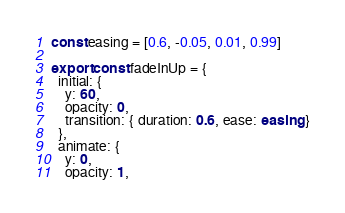Convert code to text. <code><loc_0><loc_0><loc_500><loc_500><_TypeScript_>
const easing = [0.6, -0.05, 0.01, 0.99]

export const fadeInUp = {
  initial: {
    y: 60,
    opacity: 0,
    transition: { duration: 0.6, ease: easing }
  },
  animate: {
    y: 0,
    opacity: 1,</code> 